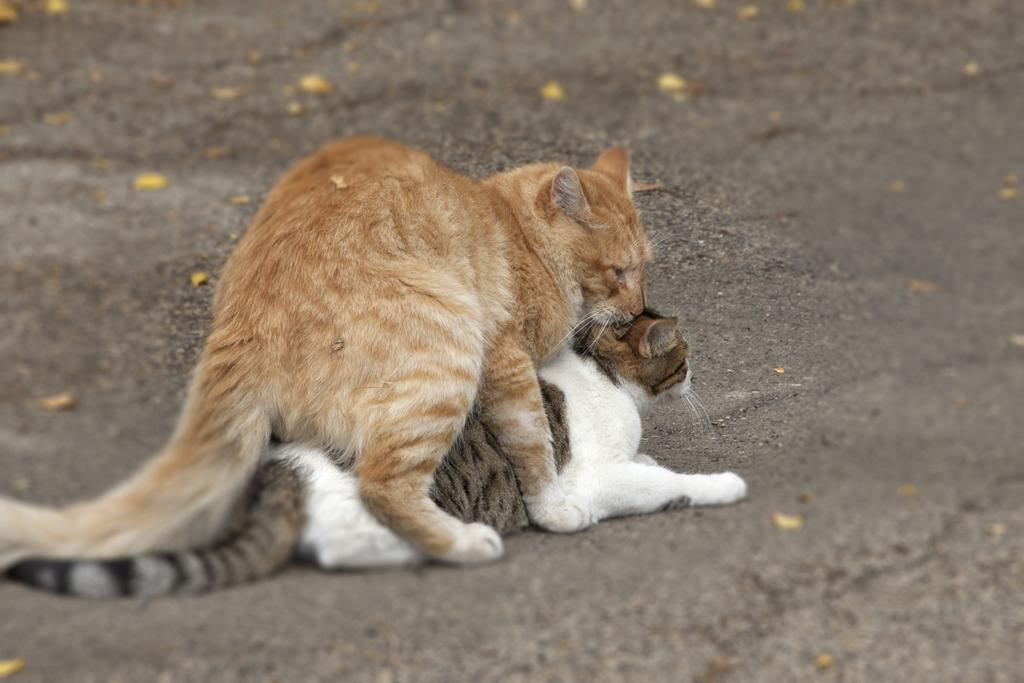Could you give a brief overview of what you see in this image? In this picture there are two cats in the center of the image one above the other. 